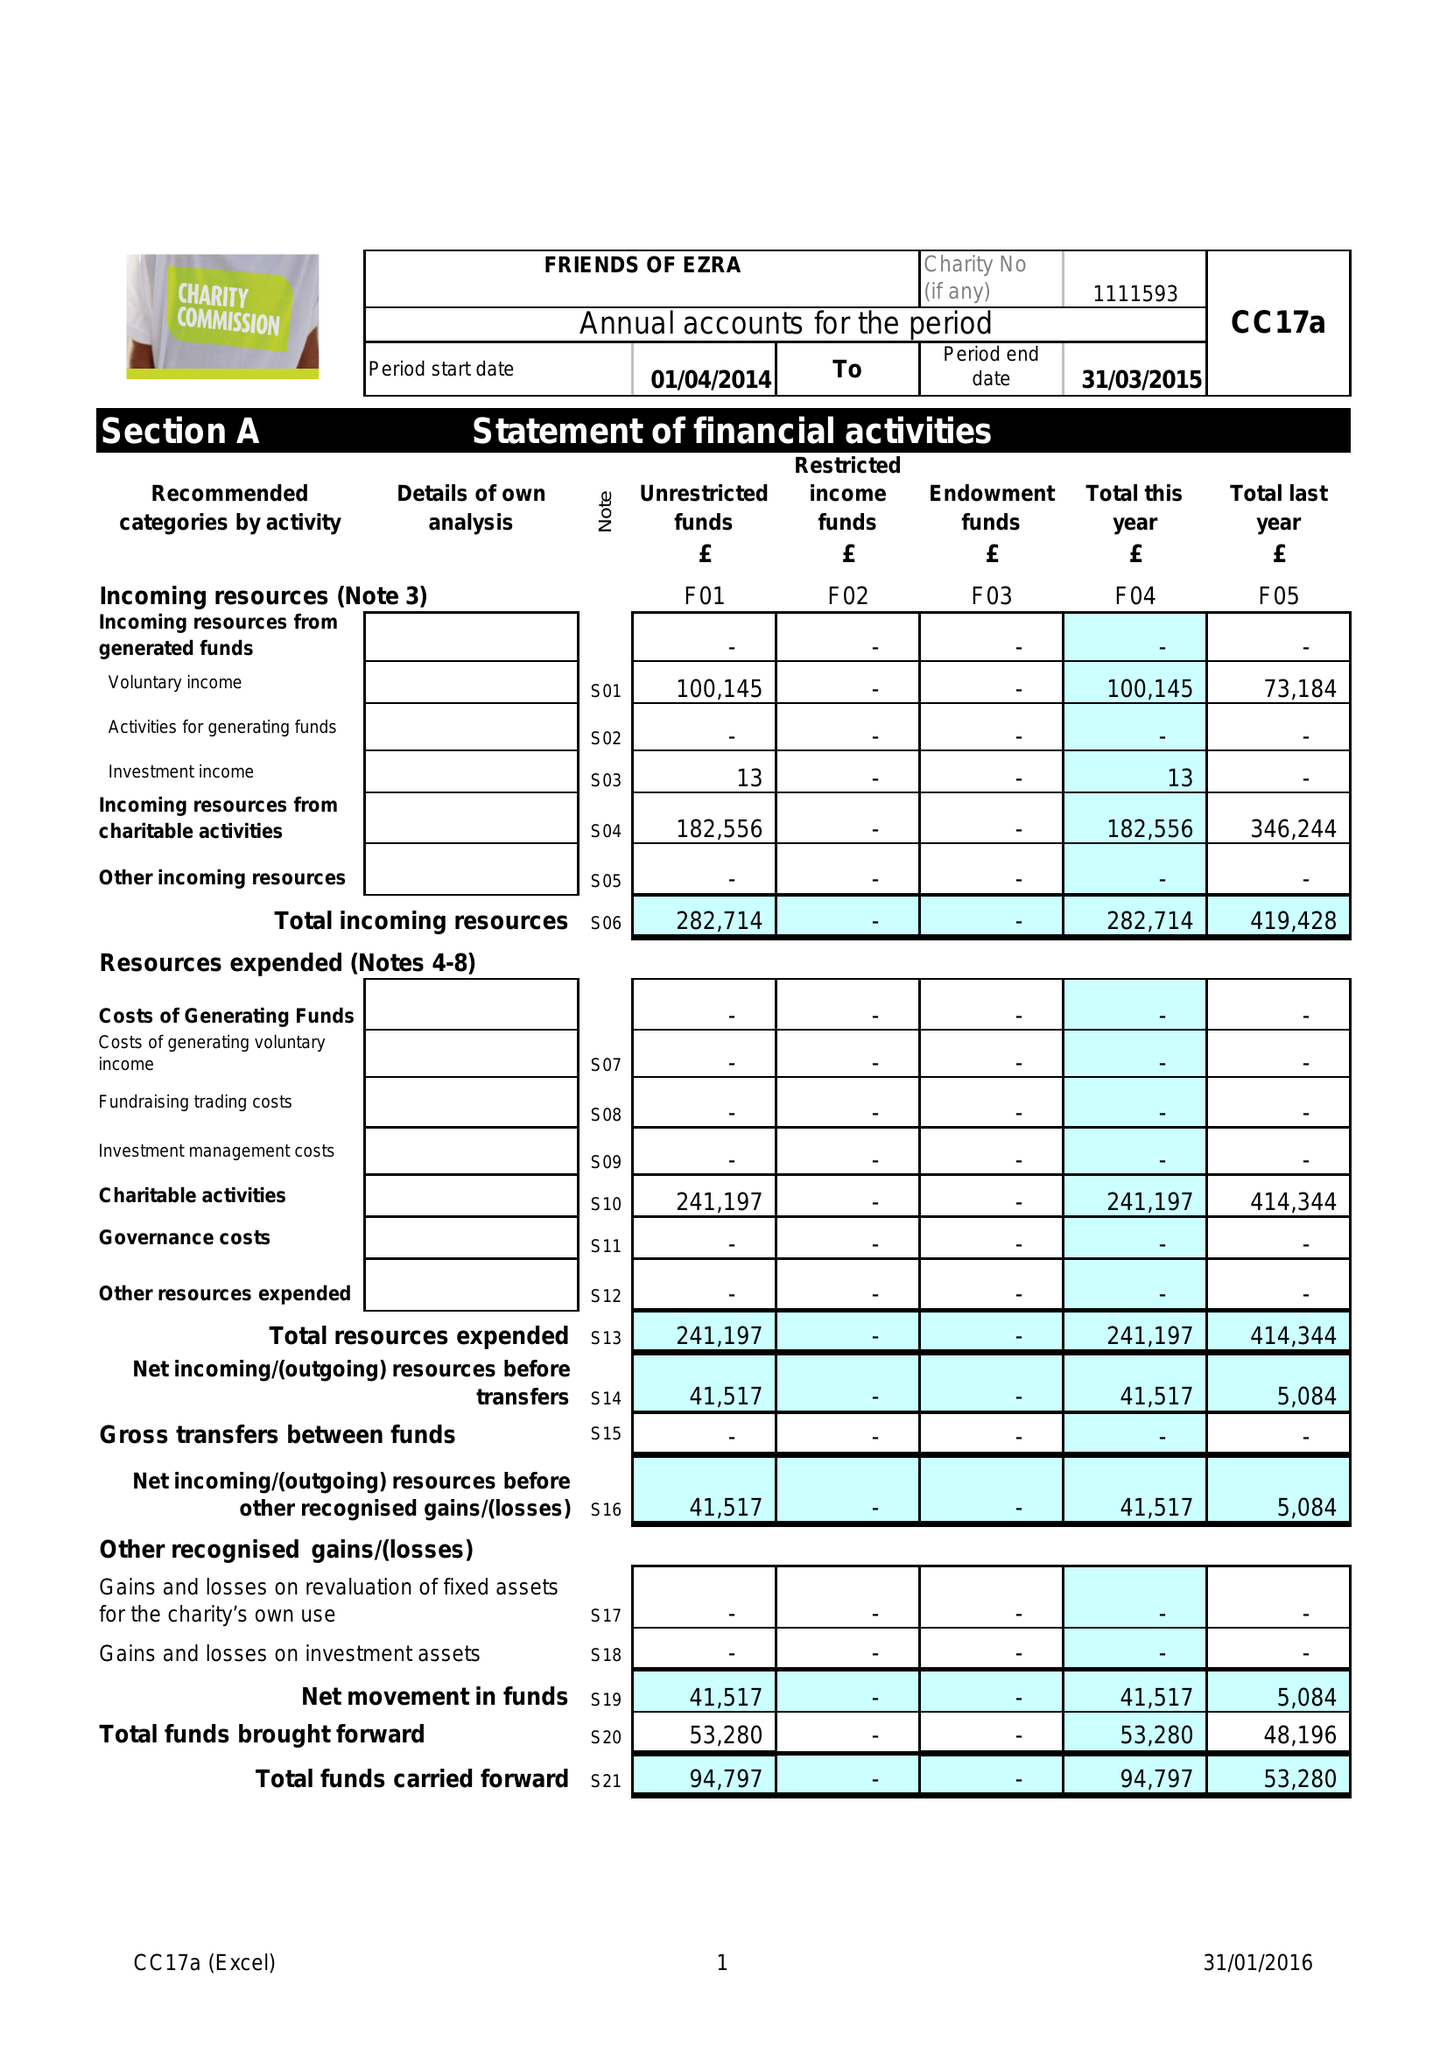What is the value for the address__street_line?
Answer the question using a single word or phrase. 35 GOLDERS GARDENS 